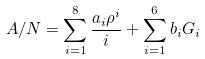Convert formula to latex. <formula><loc_0><loc_0><loc_500><loc_500>A / N = \sum _ { i = 1 } ^ { 8 } \frac { a _ { i } \rho ^ { i } } { i } + \sum _ { i = 1 } ^ { 6 } b _ { i } G _ { i }</formula> 